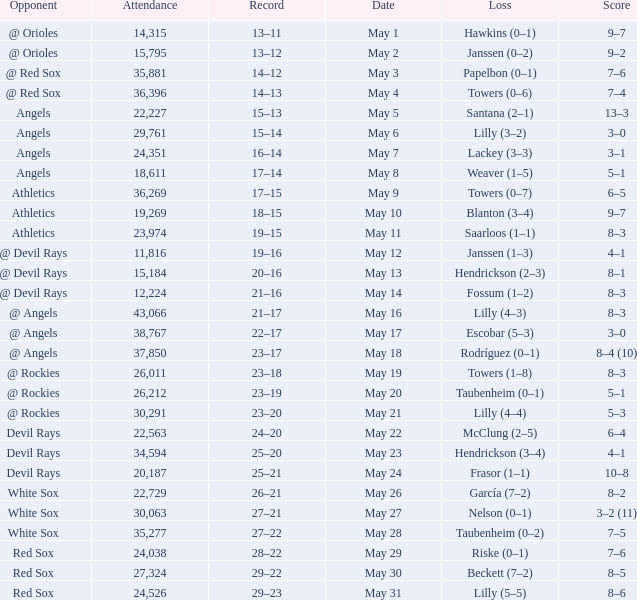When the team had their record of 16–14, what was the total attendance? 1.0. 